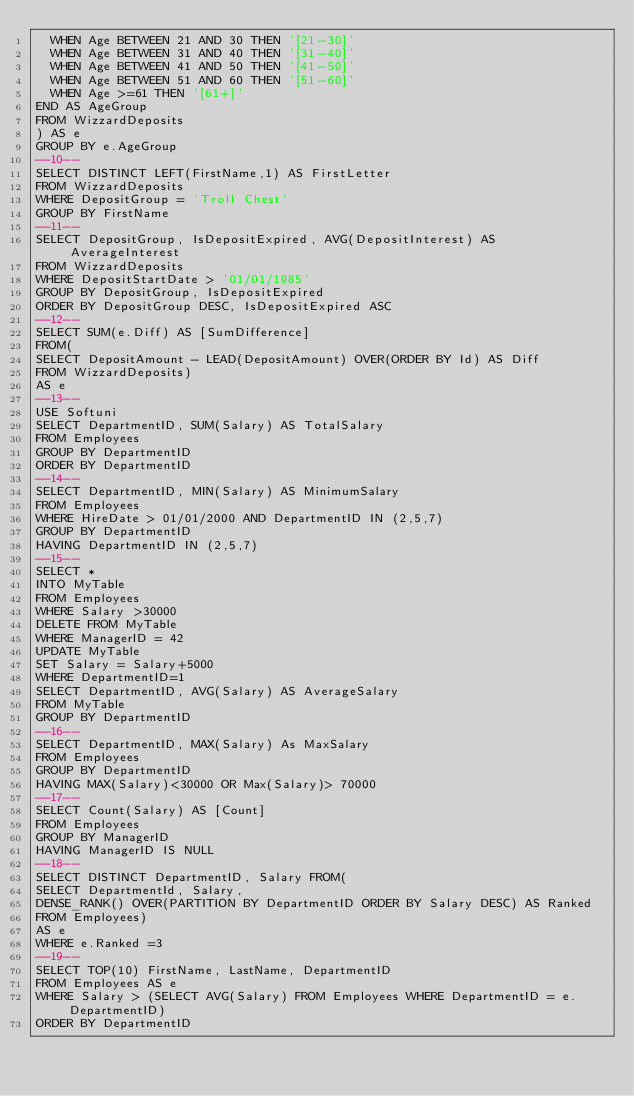Convert code to text. <code><loc_0><loc_0><loc_500><loc_500><_SQL_>	WHEN Age BETWEEN 21 AND 30 THEN '[21-30]'
	WHEN Age BETWEEN 31 AND 40 THEN '[31-40]'
	WHEN Age BETWEEN 41 AND 50 THEN '[41-50]'
	WHEN Age BETWEEN 51 AND 60 THEN '[51-60]'
	WHEN Age >=61 THEN '[61+]'
END AS AgeGroup
FROM WizzardDeposits
) AS e
GROUP BY e.AgeGroup
--10--
SELECT DISTINCT LEFT(FirstName,1) AS FirstLetter
FROM WizzardDeposits
WHERE DepositGroup = 'Troll Chest'
GROUP BY FirstName
--11--
SELECT DepositGroup, IsDepositExpired, AVG(DepositInterest) AS AverageInterest
FROM WizzardDeposits
WHERE DepositStartDate > '01/01/1985'
GROUP BY DepositGroup, IsDepositExpired
ORDER BY DepositGroup DESC, IsDepositExpired ASC
--12--
SELECT SUM(e.Diff) AS [SumDifference]
FROM(
SELECT DepositAmount - LEAD(DepositAmount) OVER(ORDER BY Id) AS Diff
FROM WizzardDeposits)
AS e
--13--
USE Softuni
SELECT DepartmentID, SUM(Salary) AS TotalSalary
FROM Employees
GROUP BY DepartmentID
ORDER BY DepartmentID
--14--
SELECT DepartmentID, MIN(Salary) AS MinimumSalary
FROM Employees
WHERE HireDate > 01/01/2000 AND DepartmentID IN (2,5,7)
GROUP BY DepartmentID
HAVING DepartmentID IN (2,5,7)
--15--
SELECT *
INTO MyTable 
FROM Employees
WHERE Salary >30000
DELETE FROM MyTable
WHERE ManagerID = 42
UPDATE MyTable
SET Salary = Salary+5000
WHERE DepartmentID=1
SELECT DepartmentID, AVG(Salary) AS AverageSalary
FROM MyTable
GROUP BY DepartmentID
--16--
SELECT DepartmentID, MAX(Salary) As MaxSalary
FROM Employees
GROUP BY DepartmentID
HAVING MAX(Salary)<30000 OR Max(Salary)> 70000
--17--
SELECT Count(Salary) AS [Count]
FROM Employees
GROUP BY ManagerID
HAVING ManagerID IS NULL
--18--
SELECT DISTINCT DepartmentID, Salary FROM(
SELECT DepartmentId, Salary,
DENSE_RANK() OVER(PARTITION BY DepartmentID ORDER BY Salary DESC) AS Ranked
FROM Employees) 
AS e
WHERE e.Ranked =3
--19--
SELECT TOP(10) FirstName, LastName, DepartmentID
FROM Employees AS e
WHERE Salary > (SELECT AVG(Salary) FROM Employees WHERE DepartmentID = e.DepartmentID)
ORDER BY DepartmentID</code> 